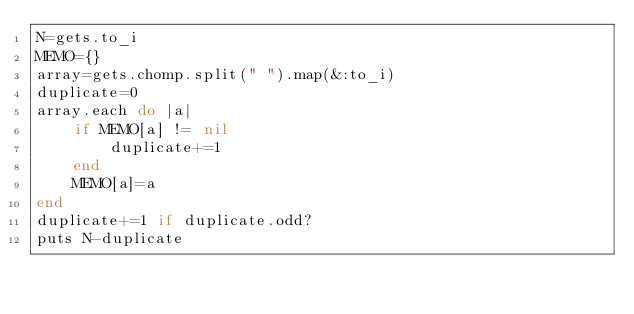<code> <loc_0><loc_0><loc_500><loc_500><_Ruby_>N=gets.to_i
MEMO={}
array=gets.chomp.split(" ").map(&:to_i)
duplicate=0
array.each do |a|
    if MEMO[a] != nil
        duplicate+=1
    end
    MEMO[a]=a
end
duplicate+=1 if duplicate.odd?
puts N-duplicate
</code> 